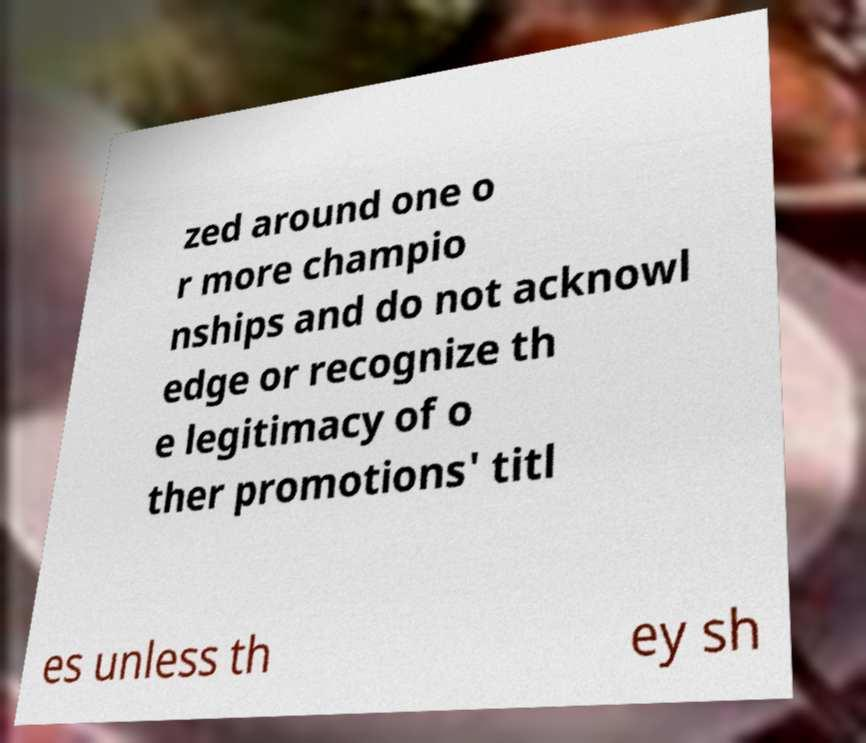Could you assist in decoding the text presented in this image and type it out clearly? zed around one o r more champio nships and do not acknowl edge or recognize th e legitimacy of o ther promotions' titl es unless th ey sh 